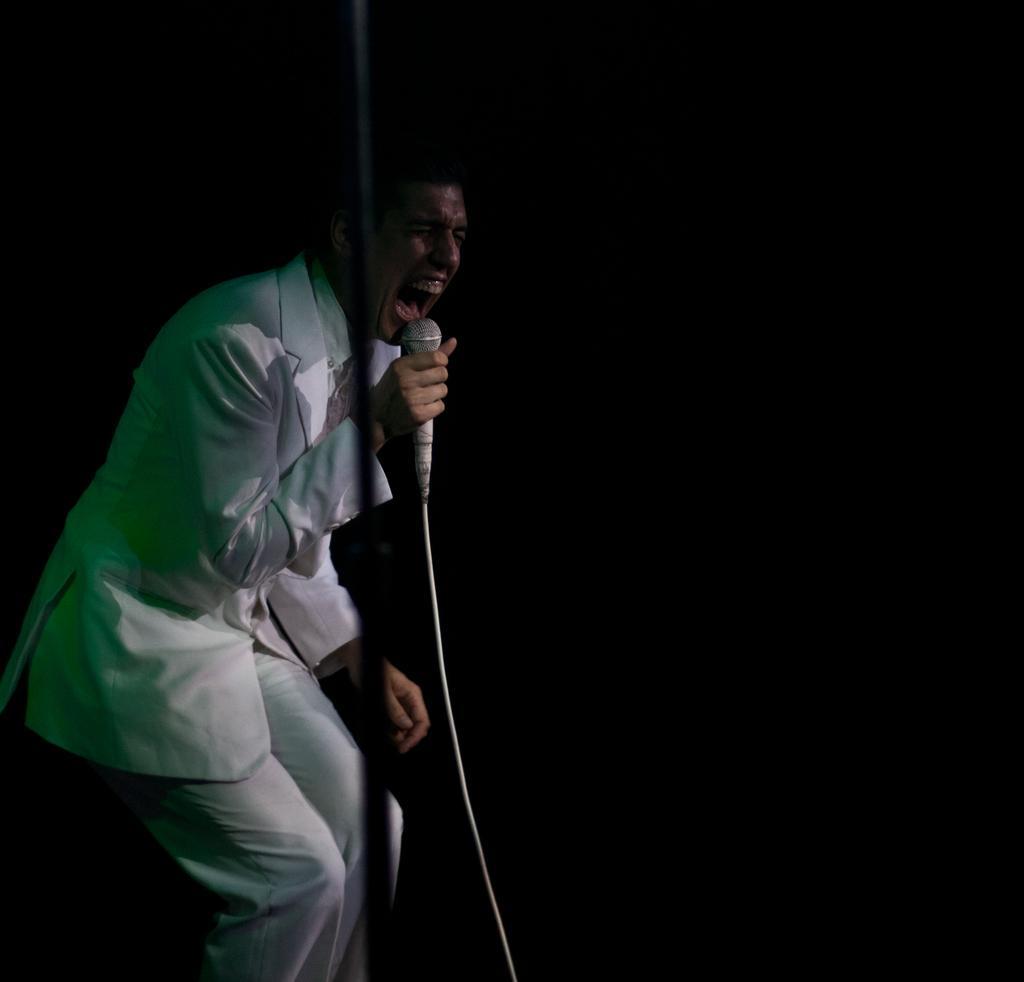Could you give a brief overview of what you see in this image? In this image we can see a person wearing a white color suit and holding a mic. 